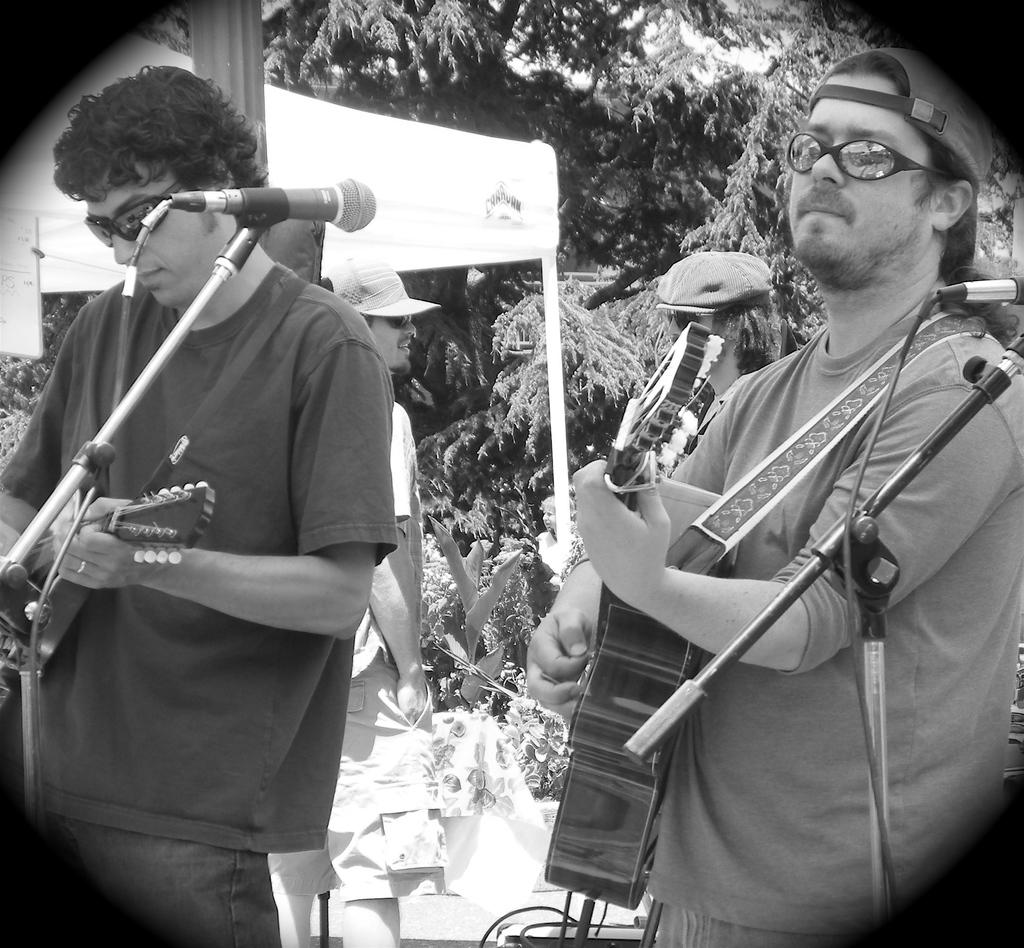What is the color scheme of the image? The image is black and white. How many people are playing musical instruments in the image? There are two men in the image, and they are playing guitar. What equipment is present for amplifying sound in the image? There are microphones with stands in the image. What can be seen in the background of the image? There are trees, a banner, and people in the background of the image. How many girls are playing the drums in the image? There are no girls or drums present in the image. What type of rhythm can be heard from the frogs in the image? There are no frogs or sounds in the image, so it is not possible to determine the rhythm. 